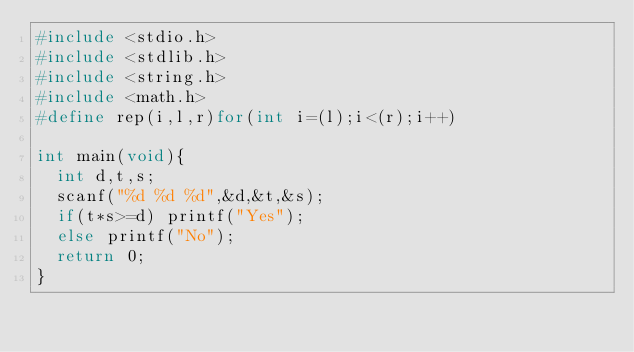Convert code to text. <code><loc_0><loc_0><loc_500><loc_500><_C_>#include <stdio.h>
#include <stdlib.h>
#include <string.h>
#include <math.h>
#define rep(i,l,r)for(int i=(l);i<(r);i++)

int main(void){
  int d,t,s;
  scanf("%d %d %d",&d,&t,&s);
  if(t*s>=d) printf("Yes");
  else printf("No");
  return 0;
}</code> 